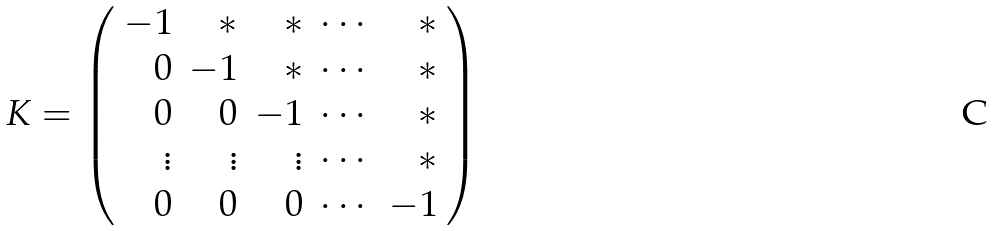Convert formula to latex. <formula><loc_0><loc_0><loc_500><loc_500>K = \left ( \begin{array} { r r r r r } - 1 & * & * & \cdots & * \\ 0 & - 1 & * & \cdots & * \\ 0 & 0 & - 1 & \cdots & * \\ \vdots & \vdots & \vdots & \cdots & * \\ 0 & 0 & 0 & \cdots & - 1 \end{array} \right )</formula> 